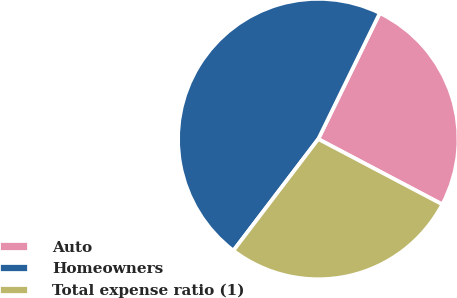Convert chart to OTSL. <chart><loc_0><loc_0><loc_500><loc_500><pie_chart><fcel>Auto<fcel>Homeowners<fcel>Total expense ratio (1)<nl><fcel>25.49%<fcel>46.88%<fcel>27.63%<nl></chart> 